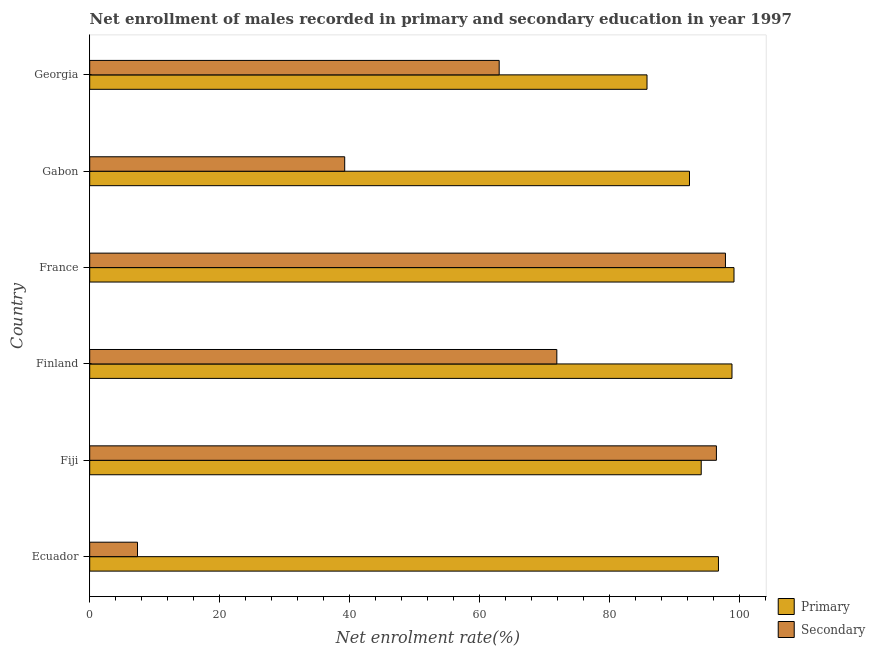How many different coloured bars are there?
Your response must be concise. 2. Are the number of bars per tick equal to the number of legend labels?
Ensure brevity in your answer.  Yes. Are the number of bars on each tick of the Y-axis equal?
Provide a succinct answer. Yes. How many bars are there on the 4th tick from the bottom?
Ensure brevity in your answer.  2. What is the label of the 6th group of bars from the top?
Offer a very short reply. Ecuador. What is the enrollment rate in secondary education in Georgia?
Provide a short and direct response. 62.98. Across all countries, what is the maximum enrollment rate in primary education?
Provide a short and direct response. 99.09. Across all countries, what is the minimum enrollment rate in primary education?
Your response must be concise. 85.72. In which country was the enrollment rate in primary education minimum?
Offer a terse response. Georgia. What is the total enrollment rate in primary education in the graph?
Offer a very short reply. 566.6. What is the difference between the enrollment rate in primary education in Finland and that in Georgia?
Your answer should be very brief. 13.07. What is the difference between the enrollment rate in secondary education in Fiji and the enrollment rate in primary education in Georgia?
Offer a very short reply. 10.67. What is the average enrollment rate in secondary education per country?
Keep it short and to the point. 62.59. What is the difference between the enrollment rate in primary education and enrollment rate in secondary education in Gabon?
Your response must be concise. 53.03. In how many countries, is the enrollment rate in secondary education greater than 68 %?
Provide a succinct answer. 3. What is the ratio of the enrollment rate in primary education in France to that in Gabon?
Provide a succinct answer. 1.07. What is the difference between the highest and the second highest enrollment rate in secondary education?
Make the answer very short. 1.39. What is the difference between the highest and the lowest enrollment rate in secondary education?
Make the answer very short. 90.43. In how many countries, is the enrollment rate in secondary education greater than the average enrollment rate in secondary education taken over all countries?
Your answer should be compact. 4. What does the 1st bar from the top in Fiji represents?
Offer a terse response. Secondary. What does the 2nd bar from the bottom in Fiji represents?
Offer a terse response. Secondary. How many bars are there?
Give a very brief answer. 12. How many countries are there in the graph?
Offer a terse response. 6. What is the difference between two consecutive major ticks on the X-axis?
Offer a terse response. 20. Where does the legend appear in the graph?
Provide a succinct answer. Bottom right. What is the title of the graph?
Your response must be concise. Net enrollment of males recorded in primary and secondary education in year 1997. Does "Excluding technical cooperation" appear as one of the legend labels in the graph?
Offer a terse response. No. What is the label or title of the X-axis?
Ensure brevity in your answer.  Net enrolment rate(%). What is the label or title of the Y-axis?
Provide a short and direct response. Country. What is the Net enrolment rate(%) of Primary in Ecuador?
Offer a very short reply. 96.7. What is the Net enrolment rate(%) of Secondary in Ecuador?
Your response must be concise. 7.35. What is the Net enrolment rate(%) of Primary in Fiji?
Give a very brief answer. 94.05. What is the Net enrolment rate(%) of Secondary in Fiji?
Provide a short and direct response. 96.39. What is the Net enrolment rate(%) of Primary in Finland?
Offer a terse response. 98.79. What is the Net enrolment rate(%) in Secondary in Finland?
Your answer should be compact. 71.85. What is the Net enrolment rate(%) in Primary in France?
Give a very brief answer. 99.09. What is the Net enrolment rate(%) of Secondary in France?
Make the answer very short. 97.78. What is the Net enrolment rate(%) of Primary in Gabon?
Offer a very short reply. 92.25. What is the Net enrolment rate(%) in Secondary in Gabon?
Provide a short and direct response. 39.22. What is the Net enrolment rate(%) of Primary in Georgia?
Provide a short and direct response. 85.72. What is the Net enrolment rate(%) in Secondary in Georgia?
Your response must be concise. 62.98. Across all countries, what is the maximum Net enrolment rate(%) in Primary?
Offer a very short reply. 99.09. Across all countries, what is the maximum Net enrolment rate(%) of Secondary?
Ensure brevity in your answer.  97.78. Across all countries, what is the minimum Net enrolment rate(%) in Primary?
Keep it short and to the point. 85.72. Across all countries, what is the minimum Net enrolment rate(%) in Secondary?
Your answer should be compact. 7.35. What is the total Net enrolment rate(%) of Primary in the graph?
Offer a terse response. 566.6. What is the total Net enrolment rate(%) in Secondary in the graph?
Offer a terse response. 375.57. What is the difference between the Net enrolment rate(%) in Primary in Ecuador and that in Fiji?
Make the answer very short. 2.65. What is the difference between the Net enrolment rate(%) of Secondary in Ecuador and that in Fiji?
Keep it short and to the point. -89.04. What is the difference between the Net enrolment rate(%) in Primary in Ecuador and that in Finland?
Provide a succinct answer. -2.08. What is the difference between the Net enrolment rate(%) in Secondary in Ecuador and that in Finland?
Provide a succinct answer. -64.49. What is the difference between the Net enrolment rate(%) in Primary in Ecuador and that in France?
Offer a very short reply. -2.39. What is the difference between the Net enrolment rate(%) in Secondary in Ecuador and that in France?
Offer a terse response. -90.43. What is the difference between the Net enrolment rate(%) in Primary in Ecuador and that in Gabon?
Provide a succinct answer. 4.46. What is the difference between the Net enrolment rate(%) in Secondary in Ecuador and that in Gabon?
Keep it short and to the point. -31.87. What is the difference between the Net enrolment rate(%) of Primary in Ecuador and that in Georgia?
Your answer should be compact. 10.99. What is the difference between the Net enrolment rate(%) in Secondary in Ecuador and that in Georgia?
Make the answer very short. -55.63. What is the difference between the Net enrolment rate(%) in Primary in Fiji and that in Finland?
Offer a terse response. -4.73. What is the difference between the Net enrolment rate(%) in Secondary in Fiji and that in Finland?
Offer a very short reply. 24.54. What is the difference between the Net enrolment rate(%) of Primary in Fiji and that in France?
Your answer should be very brief. -5.04. What is the difference between the Net enrolment rate(%) in Secondary in Fiji and that in France?
Give a very brief answer. -1.39. What is the difference between the Net enrolment rate(%) of Primary in Fiji and that in Gabon?
Give a very brief answer. 1.81. What is the difference between the Net enrolment rate(%) in Secondary in Fiji and that in Gabon?
Your response must be concise. 57.17. What is the difference between the Net enrolment rate(%) in Primary in Fiji and that in Georgia?
Your response must be concise. 8.34. What is the difference between the Net enrolment rate(%) of Secondary in Fiji and that in Georgia?
Provide a succinct answer. 33.41. What is the difference between the Net enrolment rate(%) in Primary in Finland and that in France?
Ensure brevity in your answer.  -0.31. What is the difference between the Net enrolment rate(%) of Secondary in Finland and that in France?
Provide a short and direct response. -25.93. What is the difference between the Net enrolment rate(%) in Primary in Finland and that in Gabon?
Your answer should be very brief. 6.54. What is the difference between the Net enrolment rate(%) in Secondary in Finland and that in Gabon?
Offer a very short reply. 32.62. What is the difference between the Net enrolment rate(%) of Primary in Finland and that in Georgia?
Offer a very short reply. 13.07. What is the difference between the Net enrolment rate(%) in Secondary in Finland and that in Georgia?
Give a very brief answer. 8.86. What is the difference between the Net enrolment rate(%) in Primary in France and that in Gabon?
Your response must be concise. 6.85. What is the difference between the Net enrolment rate(%) of Secondary in France and that in Gabon?
Provide a succinct answer. 58.56. What is the difference between the Net enrolment rate(%) of Primary in France and that in Georgia?
Make the answer very short. 13.38. What is the difference between the Net enrolment rate(%) in Secondary in France and that in Georgia?
Your response must be concise. 34.8. What is the difference between the Net enrolment rate(%) in Primary in Gabon and that in Georgia?
Keep it short and to the point. 6.53. What is the difference between the Net enrolment rate(%) in Secondary in Gabon and that in Georgia?
Your response must be concise. -23.76. What is the difference between the Net enrolment rate(%) of Primary in Ecuador and the Net enrolment rate(%) of Secondary in Fiji?
Your answer should be very brief. 0.31. What is the difference between the Net enrolment rate(%) of Primary in Ecuador and the Net enrolment rate(%) of Secondary in Finland?
Your response must be concise. 24.86. What is the difference between the Net enrolment rate(%) in Primary in Ecuador and the Net enrolment rate(%) in Secondary in France?
Your answer should be very brief. -1.08. What is the difference between the Net enrolment rate(%) in Primary in Ecuador and the Net enrolment rate(%) in Secondary in Gabon?
Your answer should be compact. 57.48. What is the difference between the Net enrolment rate(%) of Primary in Ecuador and the Net enrolment rate(%) of Secondary in Georgia?
Offer a very short reply. 33.72. What is the difference between the Net enrolment rate(%) of Primary in Fiji and the Net enrolment rate(%) of Secondary in Finland?
Ensure brevity in your answer.  22.21. What is the difference between the Net enrolment rate(%) of Primary in Fiji and the Net enrolment rate(%) of Secondary in France?
Your response must be concise. -3.73. What is the difference between the Net enrolment rate(%) in Primary in Fiji and the Net enrolment rate(%) in Secondary in Gabon?
Ensure brevity in your answer.  54.83. What is the difference between the Net enrolment rate(%) in Primary in Fiji and the Net enrolment rate(%) in Secondary in Georgia?
Offer a very short reply. 31.07. What is the difference between the Net enrolment rate(%) in Primary in Finland and the Net enrolment rate(%) in Secondary in Gabon?
Provide a short and direct response. 59.57. What is the difference between the Net enrolment rate(%) of Primary in Finland and the Net enrolment rate(%) of Secondary in Georgia?
Your answer should be compact. 35.81. What is the difference between the Net enrolment rate(%) in Primary in France and the Net enrolment rate(%) in Secondary in Gabon?
Provide a succinct answer. 59.87. What is the difference between the Net enrolment rate(%) of Primary in France and the Net enrolment rate(%) of Secondary in Georgia?
Give a very brief answer. 36.11. What is the difference between the Net enrolment rate(%) of Primary in Gabon and the Net enrolment rate(%) of Secondary in Georgia?
Offer a very short reply. 29.27. What is the average Net enrolment rate(%) in Primary per country?
Give a very brief answer. 94.43. What is the average Net enrolment rate(%) in Secondary per country?
Your response must be concise. 62.59. What is the difference between the Net enrolment rate(%) of Primary and Net enrolment rate(%) of Secondary in Ecuador?
Offer a terse response. 89.35. What is the difference between the Net enrolment rate(%) of Primary and Net enrolment rate(%) of Secondary in Fiji?
Keep it short and to the point. -2.34. What is the difference between the Net enrolment rate(%) of Primary and Net enrolment rate(%) of Secondary in Finland?
Your answer should be very brief. 26.94. What is the difference between the Net enrolment rate(%) of Primary and Net enrolment rate(%) of Secondary in France?
Offer a terse response. 1.31. What is the difference between the Net enrolment rate(%) in Primary and Net enrolment rate(%) in Secondary in Gabon?
Provide a short and direct response. 53.03. What is the difference between the Net enrolment rate(%) in Primary and Net enrolment rate(%) in Secondary in Georgia?
Offer a terse response. 22.74. What is the ratio of the Net enrolment rate(%) in Primary in Ecuador to that in Fiji?
Give a very brief answer. 1.03. What is the ratio of the Net enrolment rate(%) of Secondary in Ecuador to that in Fiji?
Keep it short and to the point. 0.08. What is the ratio of the Net enrolment rate(%) in Primary in Ecuador to that in Finland?
Provide a succinct answer. 0.98. What is the ratio of the Net enrolment rate(%) in Secondary in Ecuador to that in Finland?
Offer a very short reply. 0.1. What is the ratio of the Net enrolment rate(%) in Primary in Ecuador to that in France?
Make the answer very short. 0.98. What is the ratio of the Net enrolment rate(%) of Secondary in Ecuador to that in France?
Make the answer very short. 0.08. What is the ratio of the Net enrolment rate(%) of Primary in Ecuador to that in Gabon?
Your response must be concise. 1.05. What is the ratio of the Net enrolment rate(%) of Secondary in Ecuador to that in Gabon?
Keep it short and to the point. 0.19. What is the ratio of the Net enrolment rate(%) of Primary in Ecuador to that in Georgia?
Your response must be concise. 1.13. What is the ratio of the Net enrolment rate(%) of Secondary in Ecuador to that in Georgia?
Ensure brevity in your answer.  0.12. What is the ratio of the Net enrolment rate(%) in Primary in Fiji to that in Finland?
Keep it short and to the point. 0.95. What is the ratio of the Net enrolment rate(%) in Secondary in Fiji to that in Finland?
Your response must be concise. 1.34. What is the ratio of the Net enrolment rate(%) of Primary in Fiji to that in France?
Your answer should be compact. 0.95. What is the ratio of the Net enrolment rate(%) in Secondary in Fiji to that in France?
Your response must be concise. 0.99. What is the ratio of the Net enrolment rate(%) in Primary in Fiji to that in Gabon?
Keep it short and to the point. 1.02. What is the ratio of the Net enrolment rate(%) of Secondary in Fiji to that in Gabon?
Provide a succinct answer. 2.46. What is the ratio of the Net enrolment rate(%) in Primary in Fiji to that in Georgia?
Make the answer very short. 1.1. What is the ratio of the Net enrolment rate(%) of Secondary in Fiji to that in Georgia?
Keep it short and to the point. 1.53. What is the ratio of the Net enrolment rate(%) of Primary in Finland to that in France?
Offer a very short reply. 1. What is the ratio of the Net enrolment rate(%) in Secondary in Finland to that in France?
Offer a very short reply. 0.73. What is the ratio of the Net enrolment rate(%) of Primary in Finland to that in Gabon?
Ensure brevity in your answer.  1.07. What is the ratio of the Net enrolment rate(%) in Secondary in Finland to that in Gabon?
Your response must be concise. 1.83. What is the ratio of the Net enrolment rate(%) of Primary in Finland to that in Georgia?
Provide a short and direct response. 1.15. What is the ratio of the Net enrolment rate(%) of Secondary in Finland to that in Georgia?
Give a very brief answer. 1.14. What is the ratio of the Net enrolment rate(%) in Primary in France to that in Gabon?
Your answer should be very brief. 1.07. What is the ratio of the Net enrolment rate(%) in Secondary in France to that in Gabon?
Ensure brevity in your answer.  2.49. What is the ratio of the Net enrolment rate(%) of Primary in France to that in Georgia?
Give a very brief answer. 1.16. What is the ratio of the Net enrolment rate(%) in Secondary in France to that in Georgia?
Make the answer very short. 1.55. What is the ratio of the Net enrolment rate(%) of Primary in Gabon to that in Georgia?
Offer a terse response. 1.08. What is the ratio of the Net enrolment rate(%) in Secondary in Gabon to that in Georgia?
Provide a short and direct response. 0.62. What is the difference between the highest and the second highest Net enrolment rate(%) of Primary?
Your answer should be compact. 0.31. What is the difference between the highest and the second highest Net enrolment rate(%) in Secondary?
Provide a short and direct response. 1.39. What is the difference between the highest and the lowest Net enrolment rate(%) of Primary?
Keep it short and to the point. 13.38. What is the difference between the highest and the lowest Net enrolment rate(%) of Secondary?
Give a very brief answer. 90.43. 